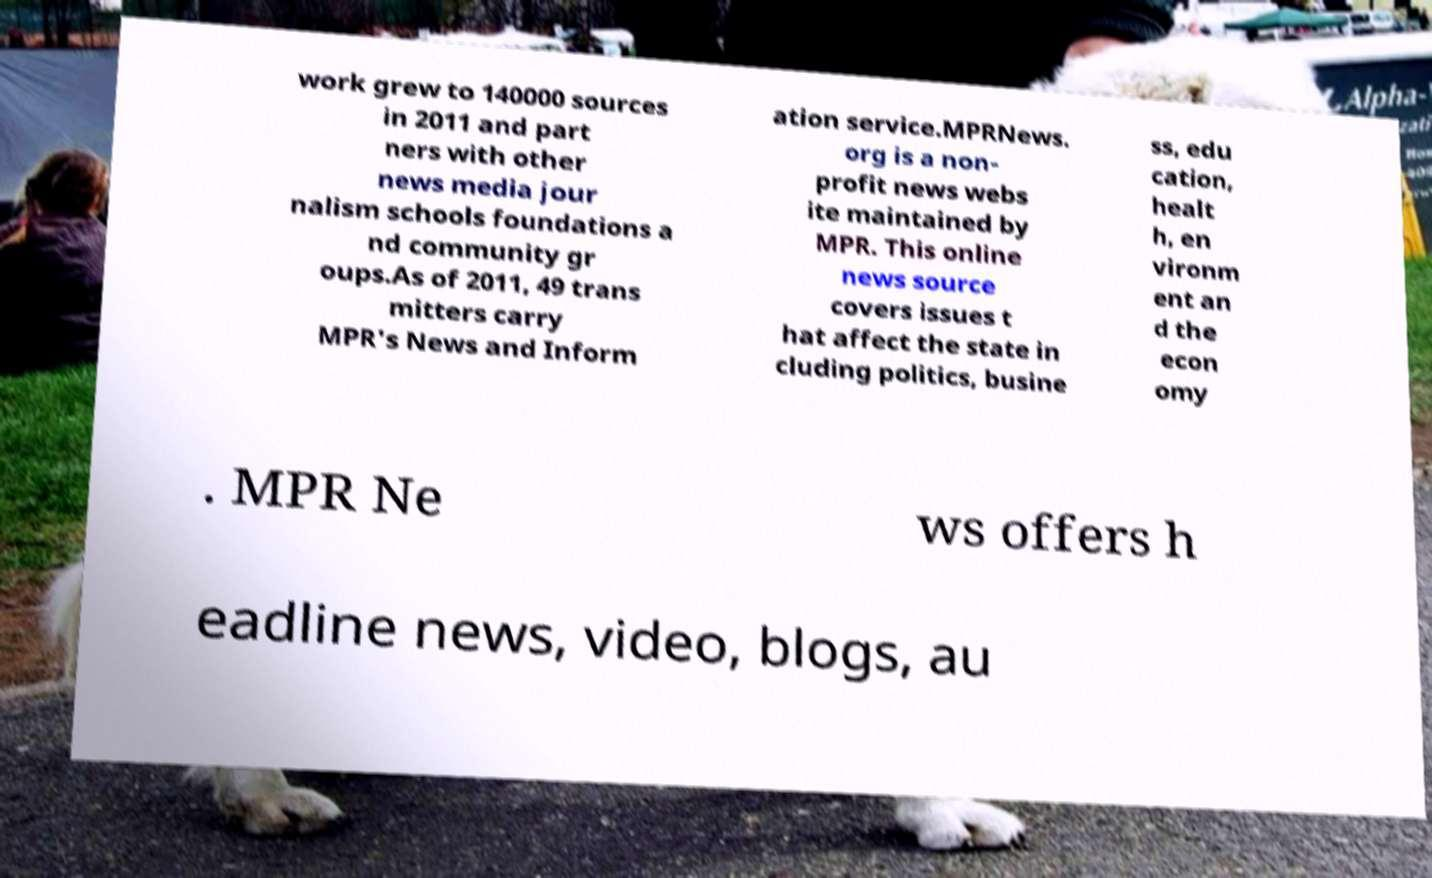Could you extract and type out the text from this image? work grew to 140000 sources in 2011 and part ners with other news media jour nalism schools foundations a nd community gr oups.As of 2011, 49 trans mitters carry MPR's News and Inform ation service.MPRNews. org is a non- profit news webs ite maintained by MPR. This online news source covers issues t hat affect the state in cluding politics, busine ss, edu cation, healt h, en vironm ent an d the econ omy . MPR Ne ws offers h eadline news, video, blogs, au 